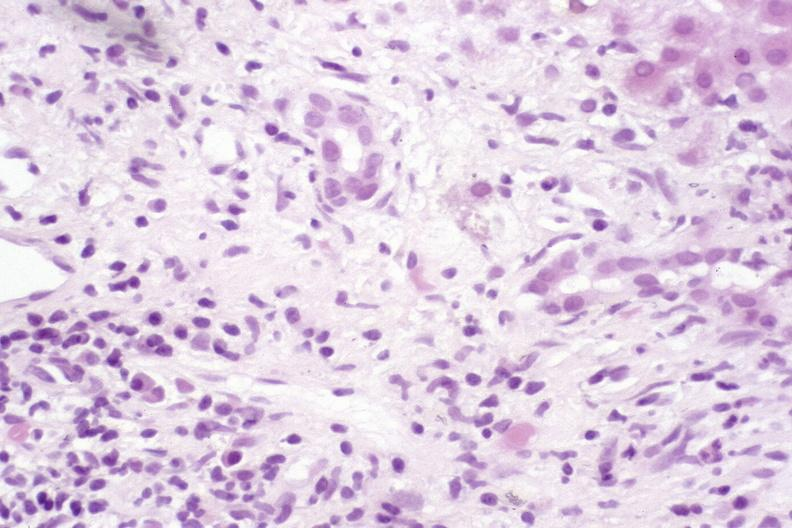s hepatobiliary present?
Answer the question using a single word or phrase. Yes 